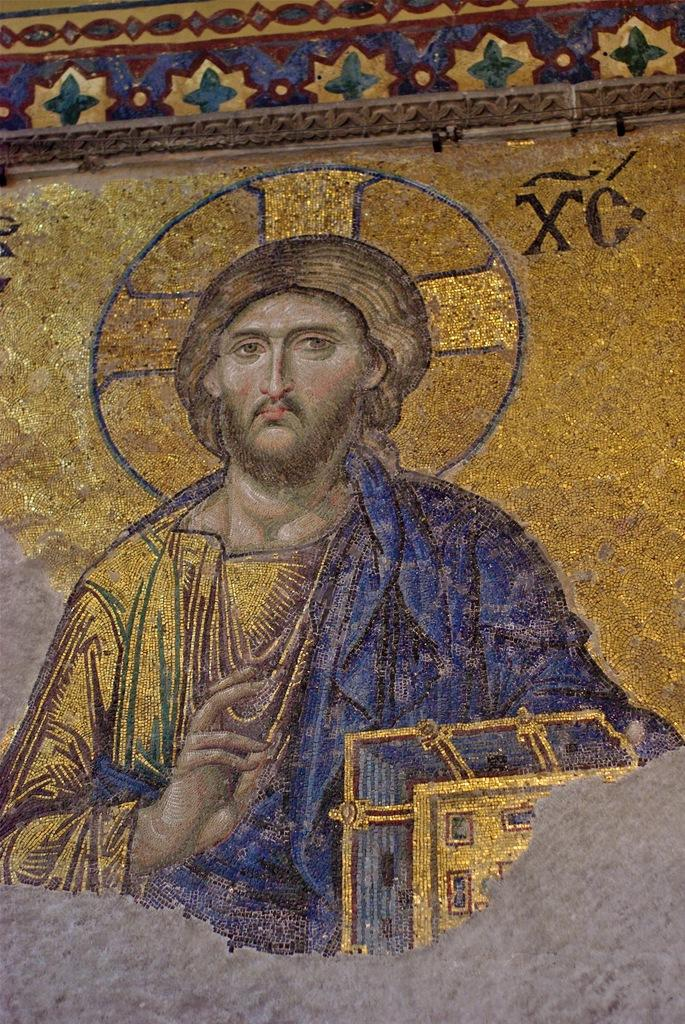What is the main subject of the image? There is a painting in the image. What does the painting depict? The painting depicts a man. Where is the painting located? The painting is on a wall. How many crows are sitting on the man's shoulder in the painting? There are no crows present in the painting; it depicts a man without any crows. 